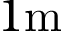Convert formula to latex. <formula><loc_0><loc_0><loc_500><loc_500>1 m</formula> 